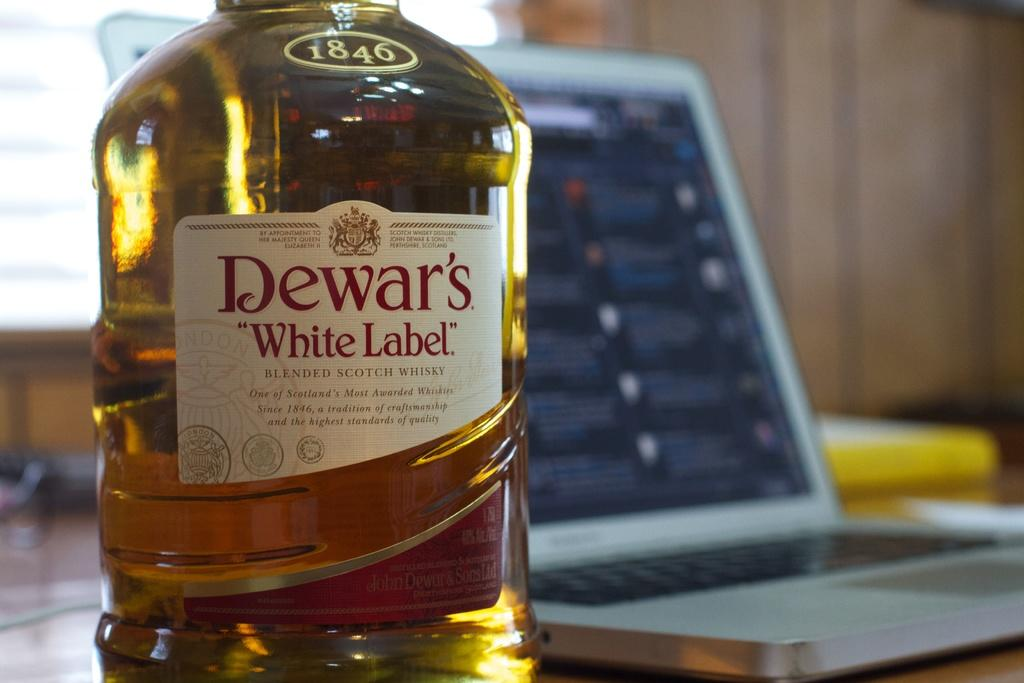<image>
Summarize the visual content of the image. 1846 Dewar's white label scotch bottle next to a laptop. 